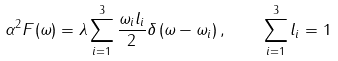<formula> <loc_0><loc_0><loc_500><loc_500>\alpha ^ { 2 } F ( \omega ) = \lambda \sum _ { i = 1 } ^ { 3 } \frac { \omega _ { i } l _ { i } } { 2 } \delta \left ( \omega - \omega _ { i } \right ) , \quad \sum _ { i = 1 } ^ { 3 } l _ { i } = 1</formula> 